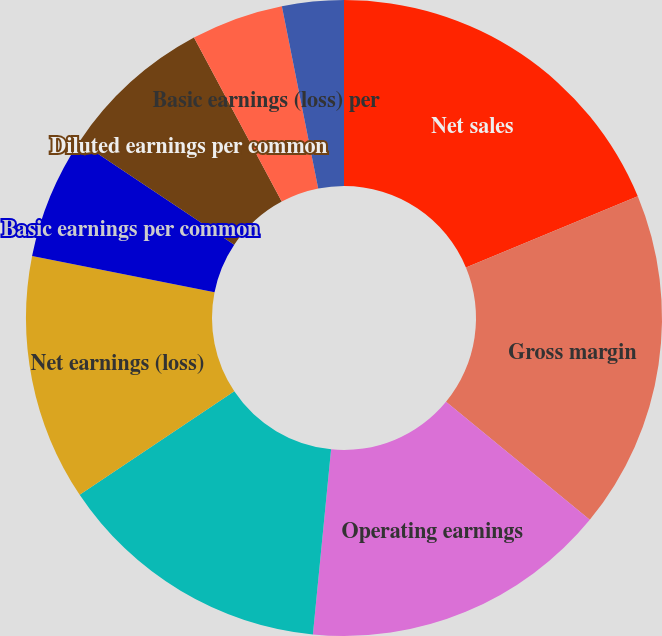<chart> <loc_0><loc_0><loc_500><loc_500><pie_chart><fcel>Net sales<fcel>Gross margin<fcel>Operating earnings<fcel>Earnings from continuing<fcel>Net earnings (loss)<fcel>Basic earnings per common<fcel>Diluted earnings per common<fcel>Basic earnings (loss) per<fcel>Diluted earnings (loss) per<fcel>Dividends declared<nl><fcel>18.75%<fcel>17.19%<fcel>15.62%<fcel>14.06%<fcel>12.5%<fcel>6.25%<fcel>7.81%<fcel>4.69%<fcel>3.13%<fcel>0.0%<nl></chart> 